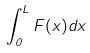Convert formula to latex. <formula><loc_0><loc_0><loc_500><loc_500>\int _ { 0 } ^ { L } F ( x ) d x</formula> 